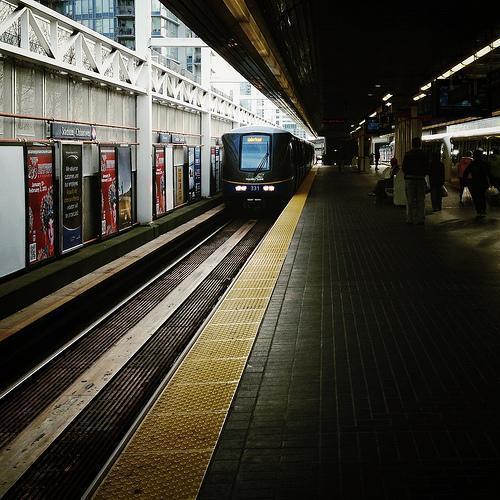How many trains are there?
Give a very brief answer. 1. 